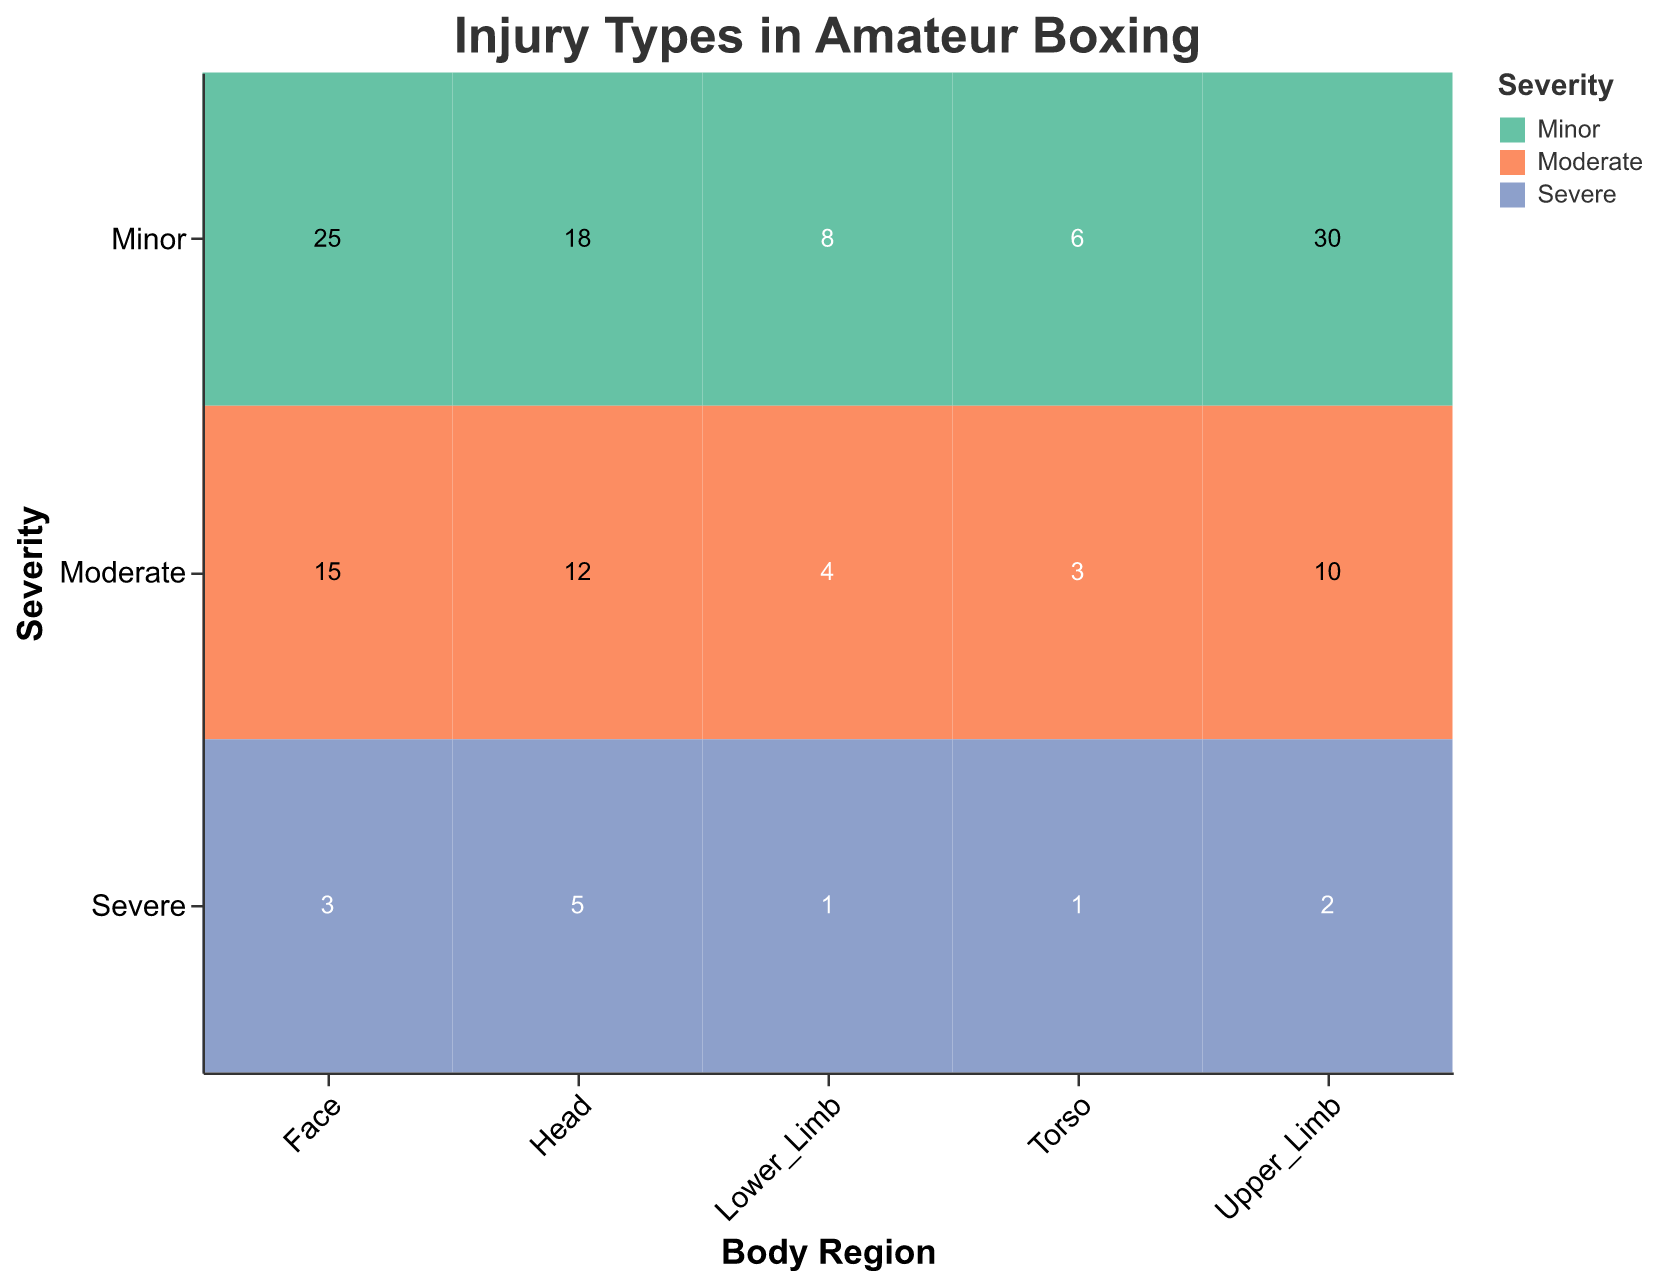What is the total number of minor injuries? Refer to the cells with "Minor" severity across all body regions and sum their frequencies: 18 (Head) + 25 (Face) + 30 (Upper_Limb) + 8 (Lower_Limb) + 6 (Torso) = 87
Answer: 87 Which body region has the highest number of total injuries? Add the injuries (Minor, Moderate, and Severe) for each body region and compare them. Head: 18 + 12 + 5 = 35, Face: 25 + 15 + 3 = 43, Upper_Limb: 30 + 10 + 2 = 42, Lower_Limb: 8 + 4 + 1 = 13, Torso: 6 + 3 + 1 = 10. The highest is Face with a total of 43 injuries
Answer: Face How many severe injuries are in the Upper_Limb region? Refer to the cell corresponding to "Upper_Limb" and "Severe" and read its frequency, which is 2
Answer: 2 Which severity level has the fewest number of injuries in the Torso region? Compare the frequency numbers across "Torso" for each severity level: Minor: 6, Moderate: 3, Severe: 1. The fewest number of injuries is in the "Severe" category
Answer: Severe What is the frequency of moderate injuries in the Head region? Refer to the cell corresponding to "Head" and "Moderate" and read its frequency, which is 12
Answer: 12 Which body region has the greatest number of severe injuries? Compare the "Severe" injuries across all body regions: Head: 5, Face: 3, Upper_Limb: 2, Lower_Limb: 1, Torso: 1. The greatest number of severe injuries is in the Head with a frequency of 5
Answer: Head Which body region has fewer than 10 total moderate injuries? Summing up the moderate injuries for each region: Head: 12, Face: 15, Upper_Limb: 10, Lower_Limb: 4, Torso: 3. Lower_Limb and Torso have fewer than 10 moderate injuries, but the question asks for one region, so we choose Lower_Limb first
Answer: Lower_Limb If combined, how many severe injuries are in the Head and Face regions? Sum the severe injuries in both regions: Head (5) + Face (3) = 8
Answer: 8 What is the ratio of minor to severe injuries in the Face region? Refer to the Face region frequencies for "Minor" (25) and "Severe" (3) and calculate the ratio: 25/3
Answer: 8.33 